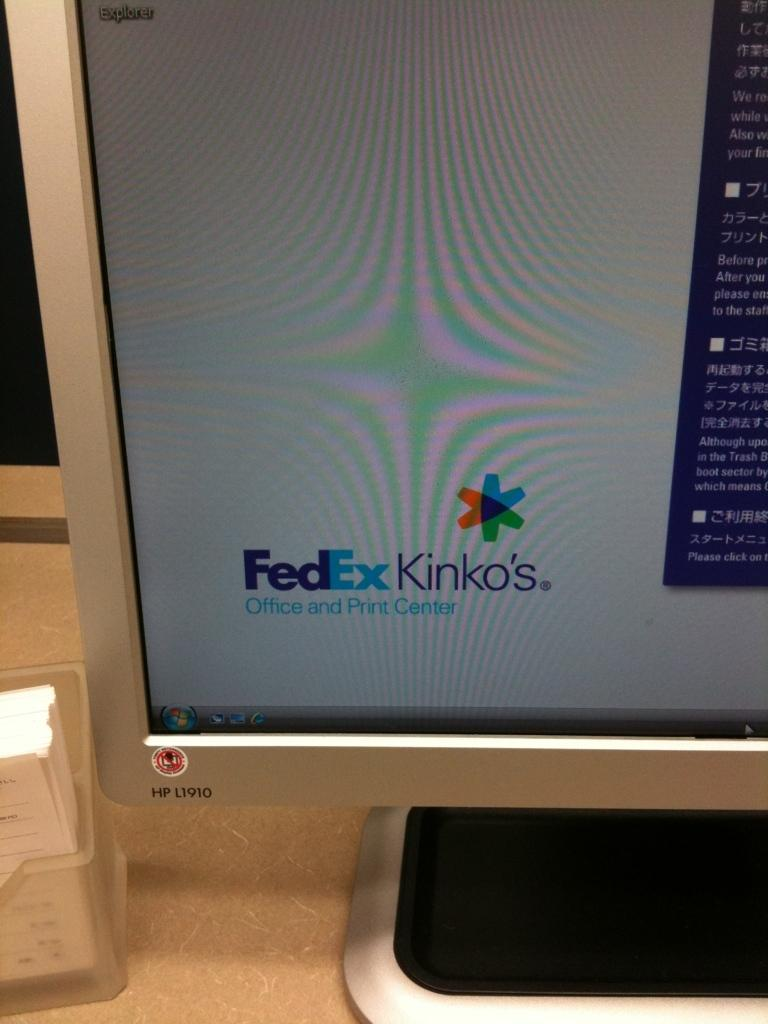<image>
Write a terse but informative summary of the picture. The lower left corner of a computer screen shows the FedEx Kinko's logo. 